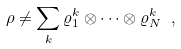<formula> <loc_0><loc_0><loc_500><loc_500>\rho \neq \sum _ { k } \varrho _ { 1 } ^ { k } \otimes \cdots \otimes \varrho _ { N } ^ { k } \ ,</formula> 